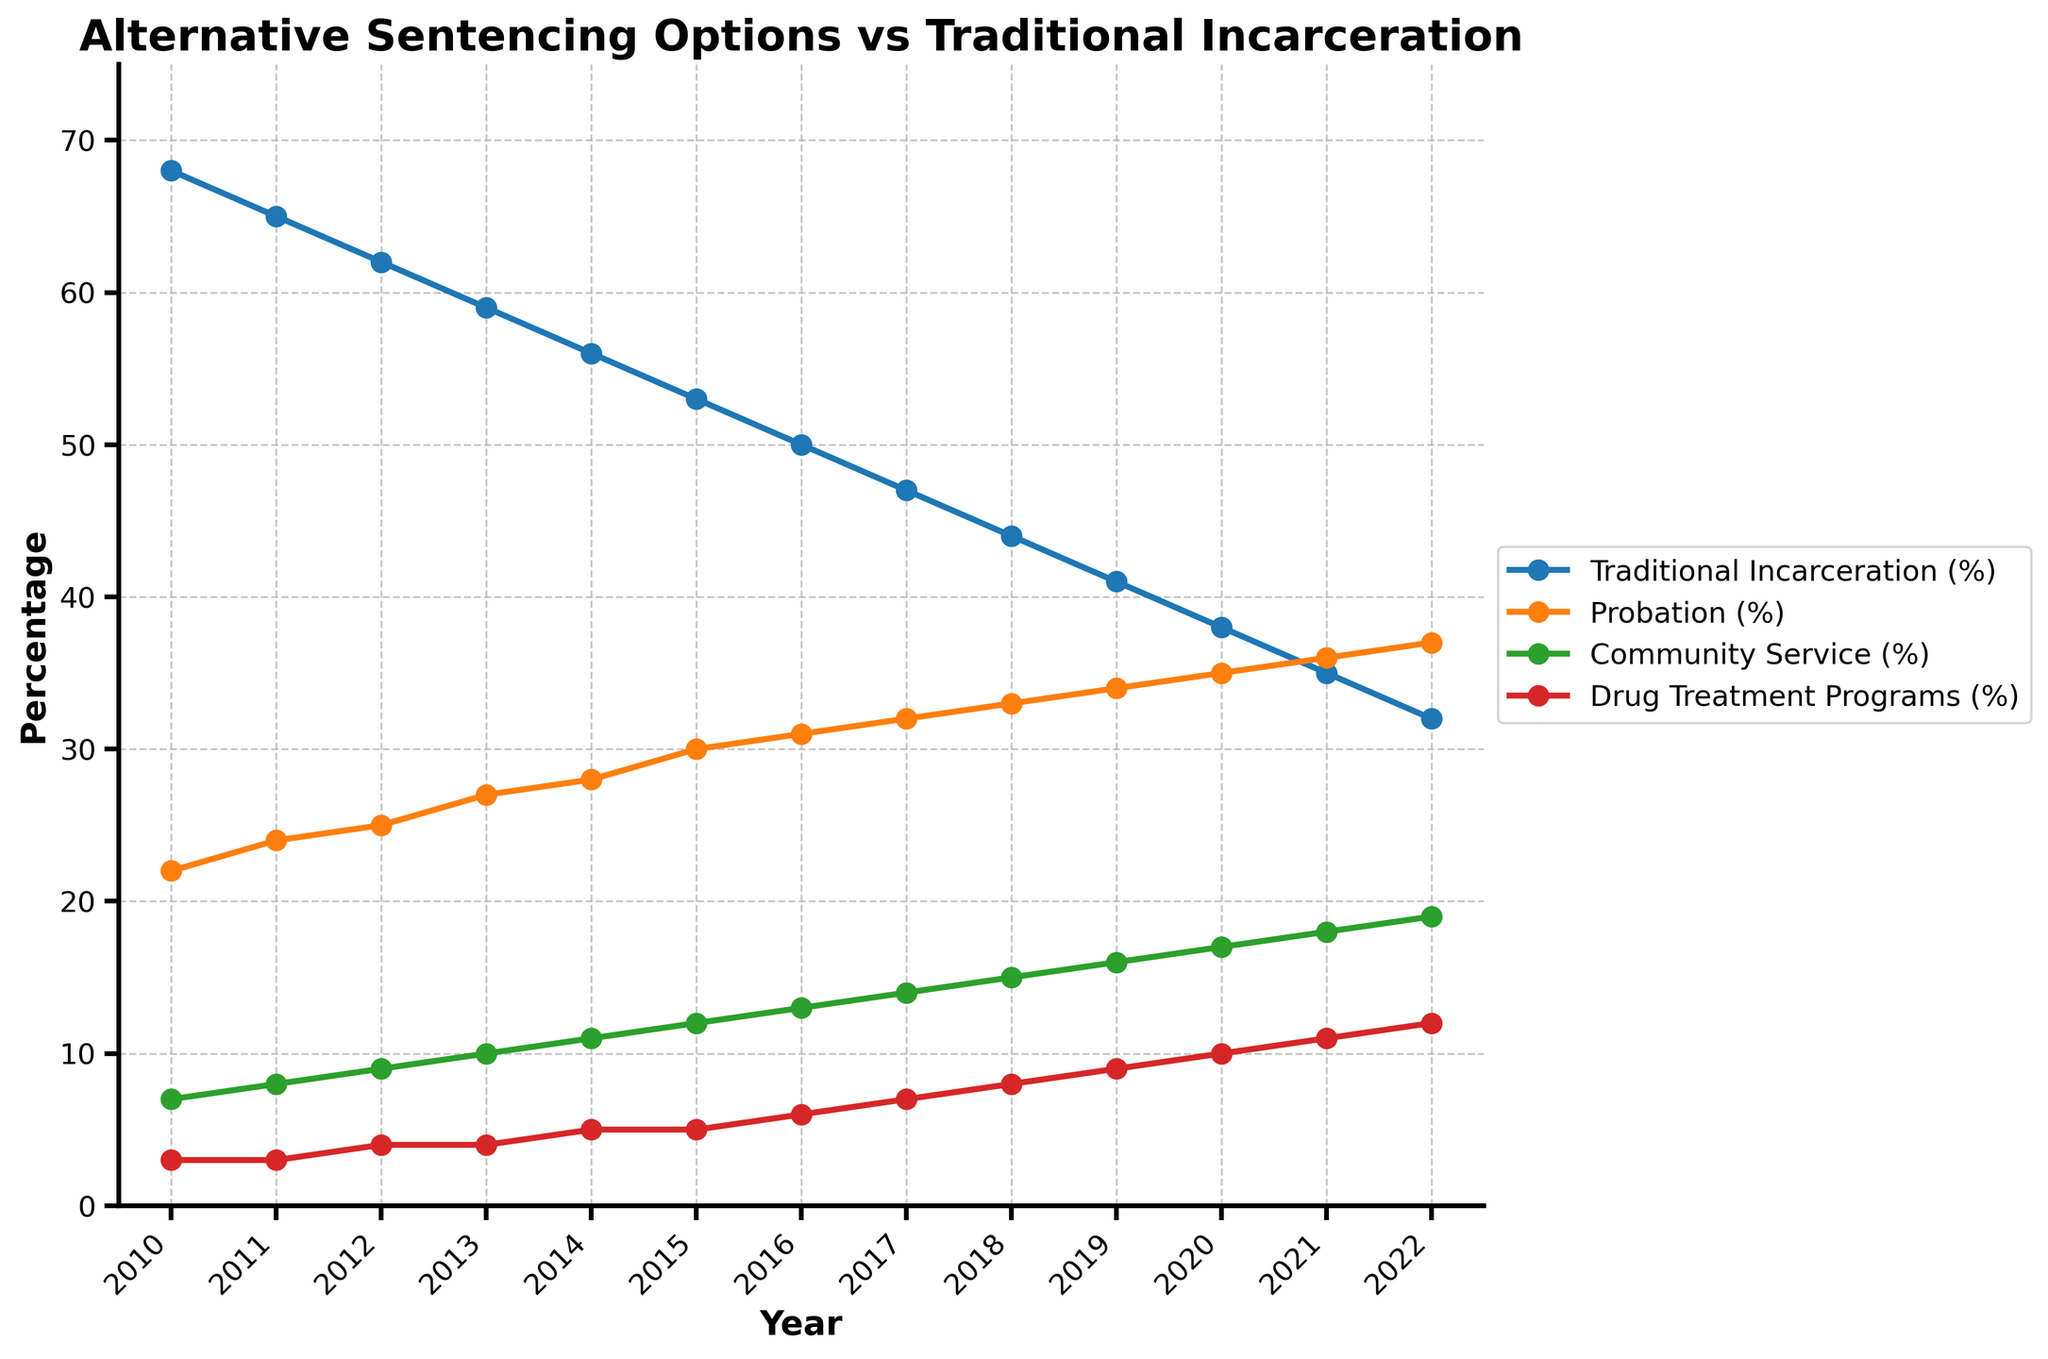What alternative sentencing option saw the most significant increase between 2010 and 2022? To determine the most significant increase, look at the initial and final values for each option. Probation increased from 22% to 37%, Community Service from 7% to 19%, and Drug Treatment Programs from 3% to 12%. Community Service saw the greatest increase.
Answer: Community Service How did the percentage of traditional incarceration change from 2010 to 2022? Traditional incarceration decreased from 68% in 2010 to 32% in 2022. Calculate the difference: 68% - 32% = 36%.
Answer: Decreased by 36% Which year saw the highest percentage of probation as an alternative sentencing option? Check the probation percentage for each year and find the highest value. The highest percentage is 37% in 2022.
Answer: 2022 What was the combined percentage of community service and drug treatment programs in 2016? Add the percentages for community service (13%) and drug treatment programs (6%): 13% + 6% = 19%.
Answer: 19% Compare the trends of traditional incarceration and probation over the years. Which one shows a decreasing trend? Observe the lines for traditional incarceration and probation. Traditional incarceration is decreasing, while probation is increasing.
Answer: Traditional Incarceration Which year had a higher percentage of drug treatment programs: 2011 or 2015? Compare the percentages of drug treatment programs for both years. In 2011, it's 3%, and in 2015, it's 5%.
Answer: 2015 What is the average percentage of traditional incarceration between 2010 and 2022? Sum up the percentages from 2010 to 2022 (68 + 65 + 62 + 59 + 56 + 53 + 50 + 47 + 44 + 41 + 38 + 35 + 32 = 650) and divide by the number of years (13): 650 / 13 ≈ 50%.
Answer: 50% Between 2017 and 2020, which alternative sentencing option showed the most growth? To find this, look at the percentage increase for each option between 2017 and 2020. Increase for probation: 35% - 32% = 3%, community service: 17% - 14% = 3%, drug treatment programs: 10% - 7% = 3%. All show equal growth.
Answer: All equal What percentage of cases resulted in probation in 2015? Simply refer to the value indicated for probation in 2015, which is 30%.
Answer: 30% In which year did the percentage of probation equal 32%? Check the years and their corresponding probation values to find when it hit 32%. It was in 2017.
Answer: 2017 